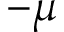<formula> <loc_0><loc_0><loc_500><loc_500>- \mu</formula> 